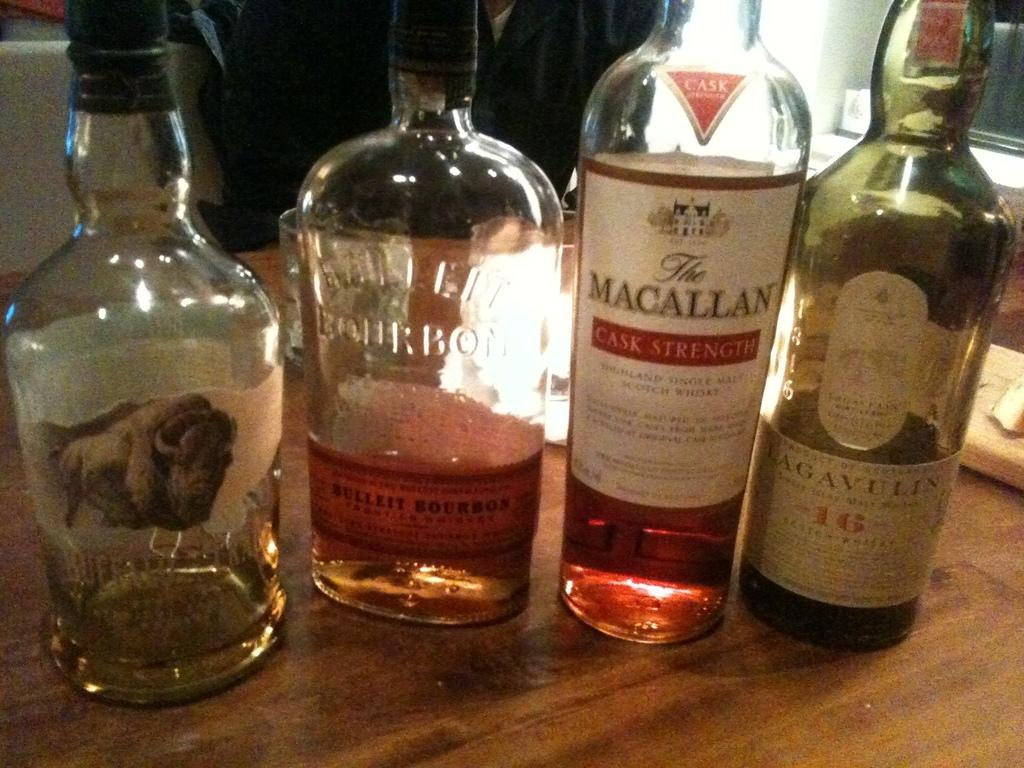What types of alcoholic beverages are visible in the image? There are whisky bottles and wine bottles in the image. Where are the bottles located? The bottles are on a table. Can you describe the presence of any people in the image? There is a person in the background of the image. What type of swing can be seen in the image? There is no swing present in the image. Is there a girl playing with the whisky bottles in the image? There is no girl or any indication of play in the image; it features whisky and wine bottles on a table with a person in the background. 